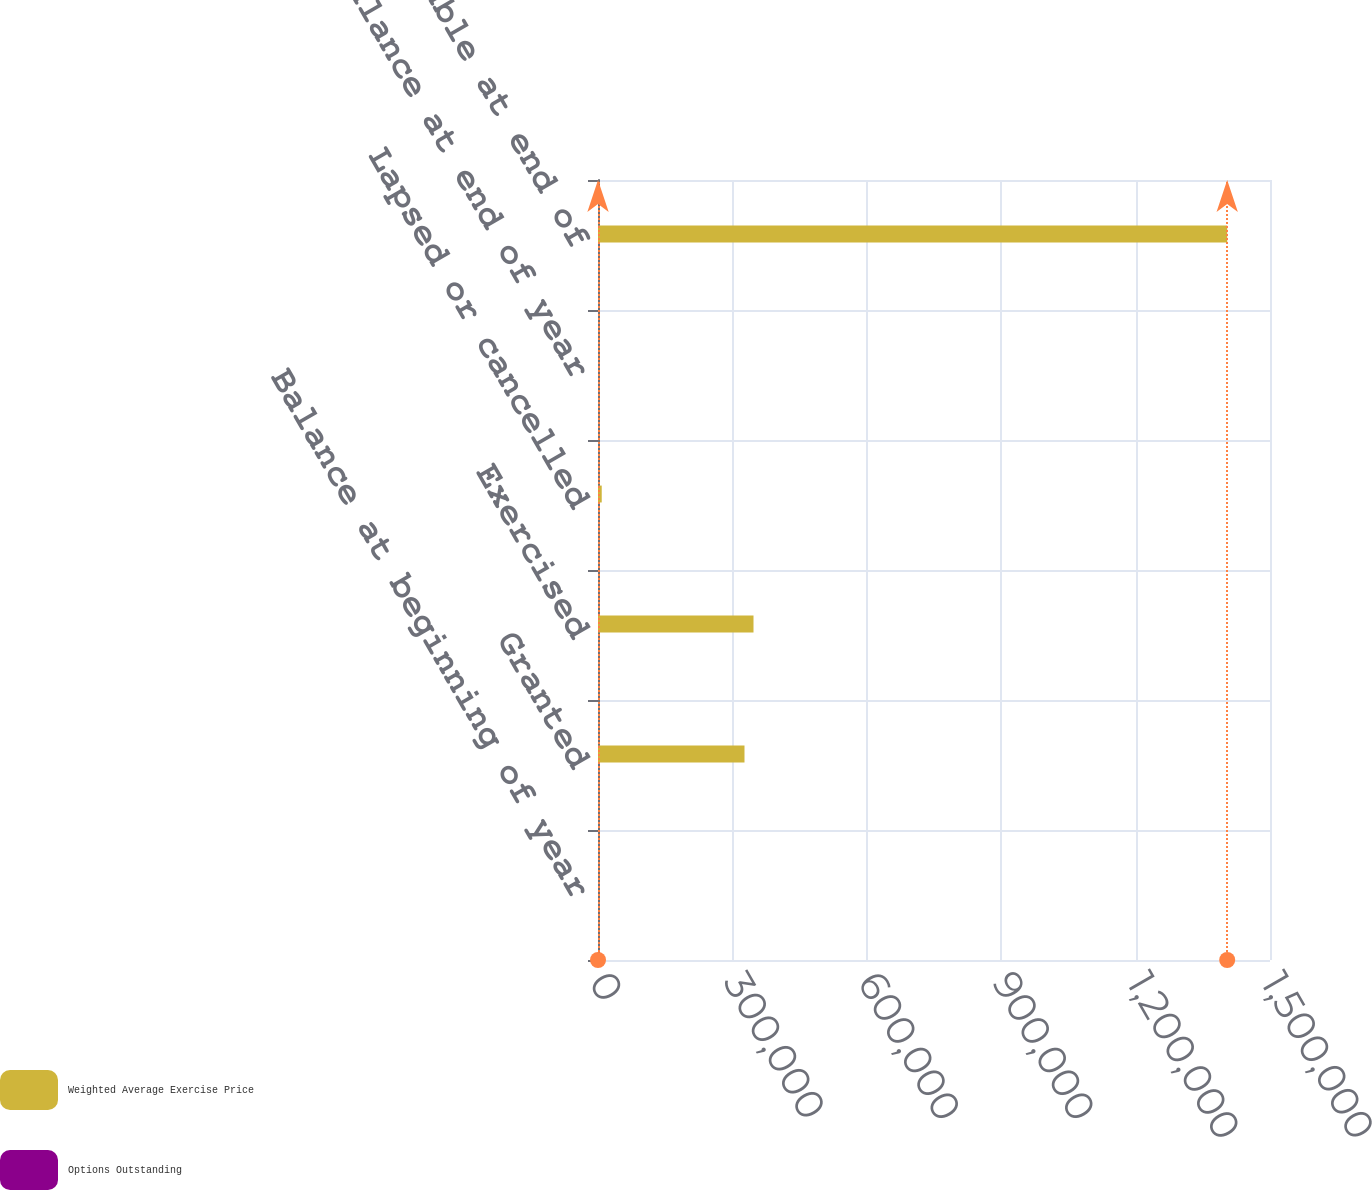<chart> <loc_0><loc_0><loc_500><loc_500><stacked_bar_chart><ecel><fcel>Balance at beginning of year<fcel>Granted<fcel>Exercised<fcel>Lapsed or cancelled<fcel>Balance at end of year<fcel>Options exercisable at end of<nl><fcel>Weighted Average Exercise Price<fcel>30.945<fcel>327000<fcel>347099<fcel>8333<fcel>30.945<fcel>1.40447e+06<nl><fcel>Options Outstanding<fcel>25.49<fcel>35.09<fcel>22.14<fcel>24.52<fcel>26.8<fcel>23.41<nl></chart> 